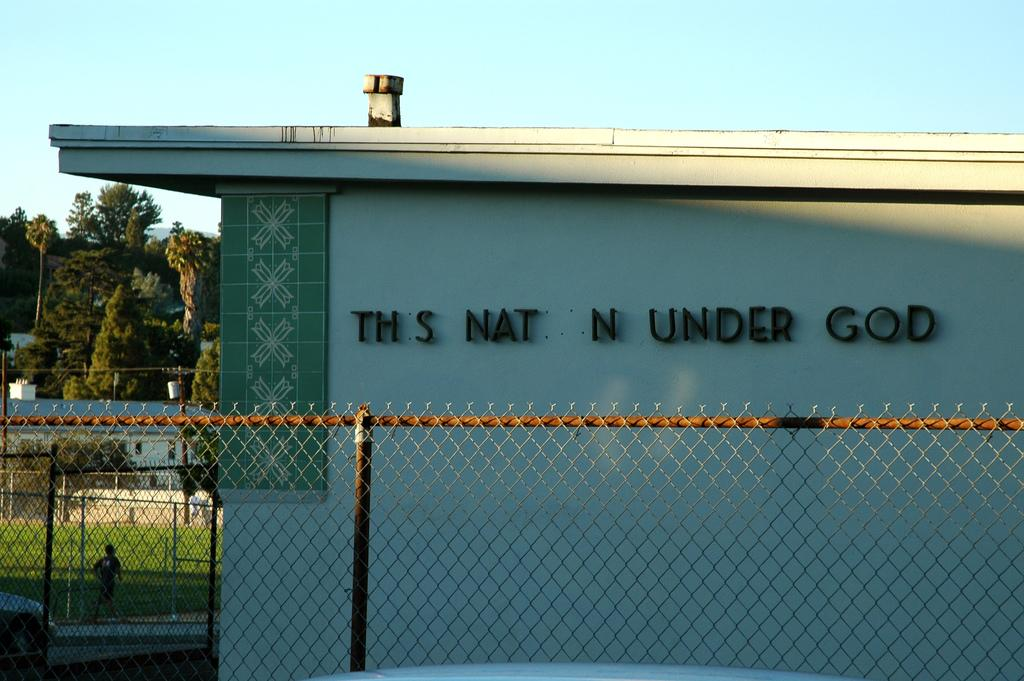What type of material is used for the rods in the image? The rods in the image are made of metal. What structure is present in the image that uses these rods? There is a fence in the image that uses the metal rods. What type of building can be seen in the image? There is a house in the image. What is the person in the background of the image doing? The person is walking on the grass in the background of the image. What other structures are visible in the image? There are poles visible in the image. What type of natural environment is visible in the background of the image? There are trees in the background of the image. How many cakes are being eaten by the person walking on the grass in the image? There are no cakes present in the image; the person is walking on the grass. Can you describe the hole in the image? There is no hole present in the image. 